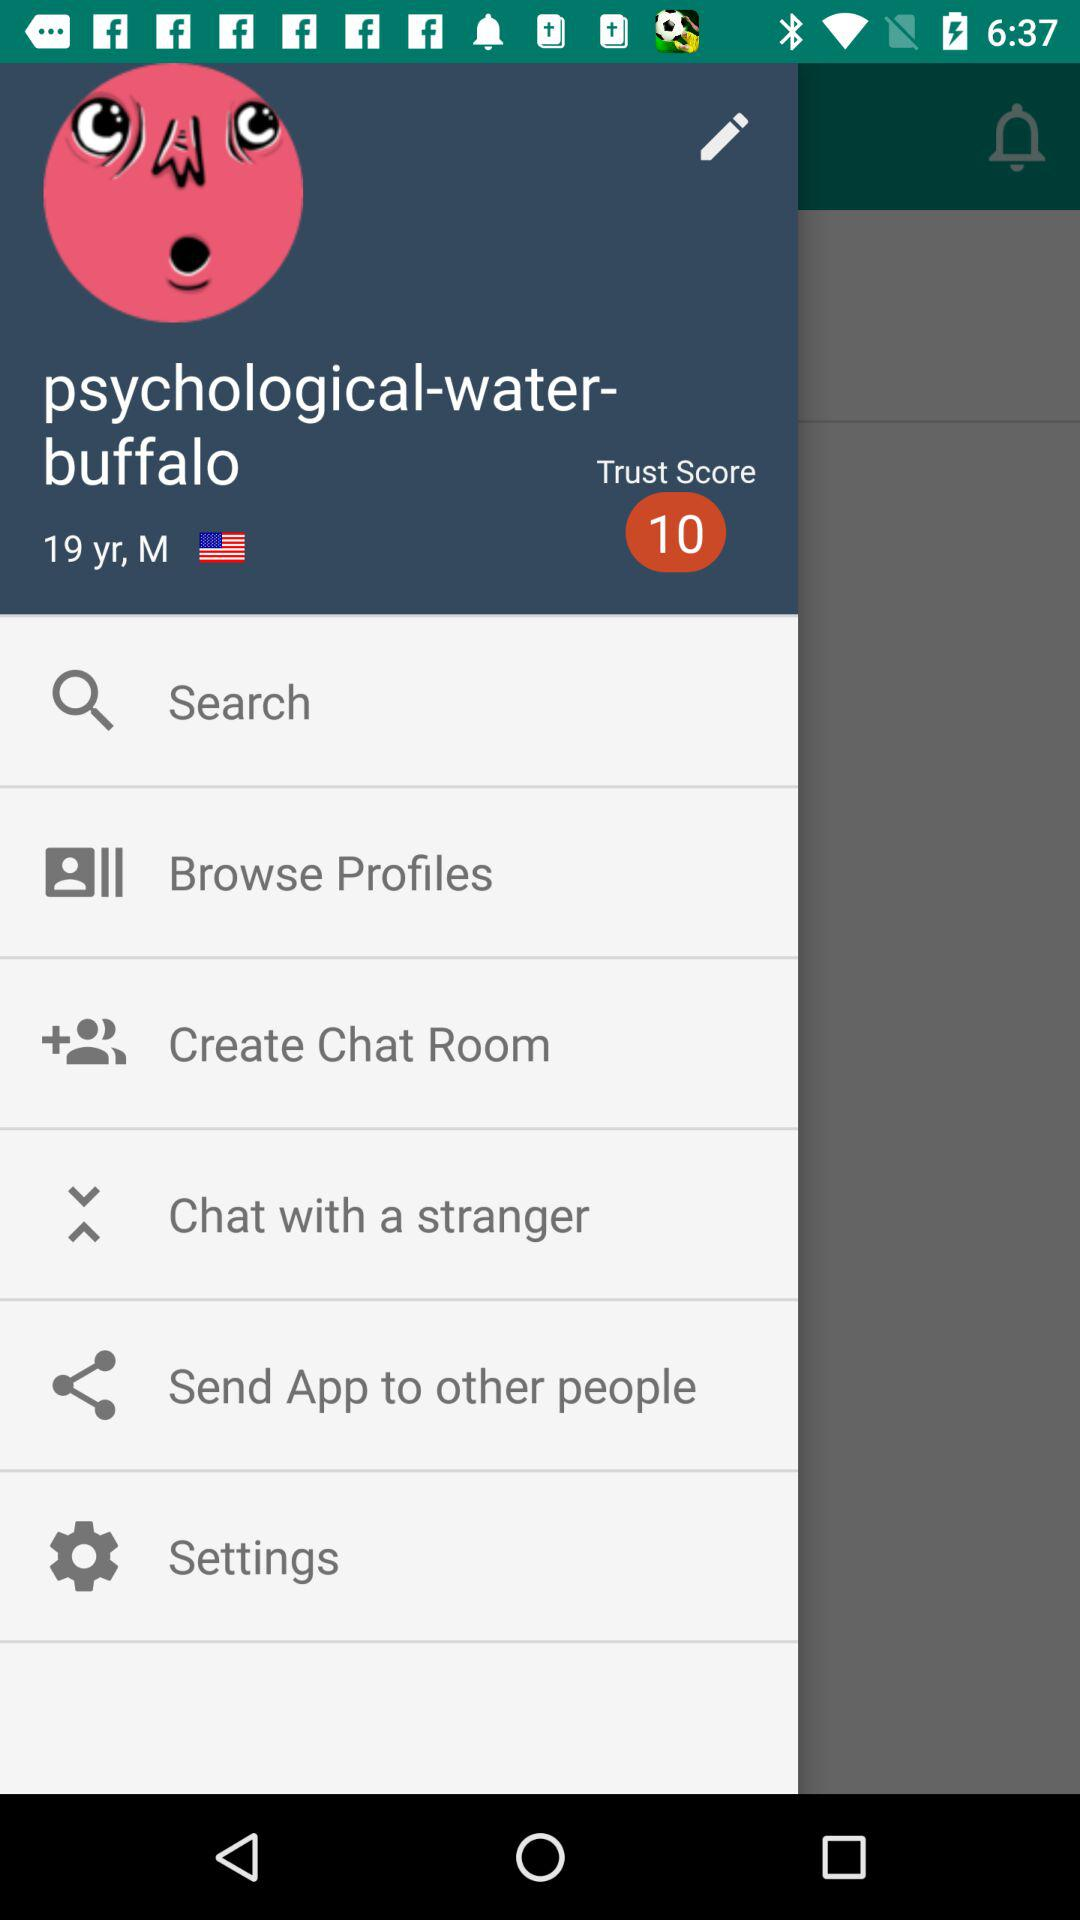What is the gender? The gender is male. 